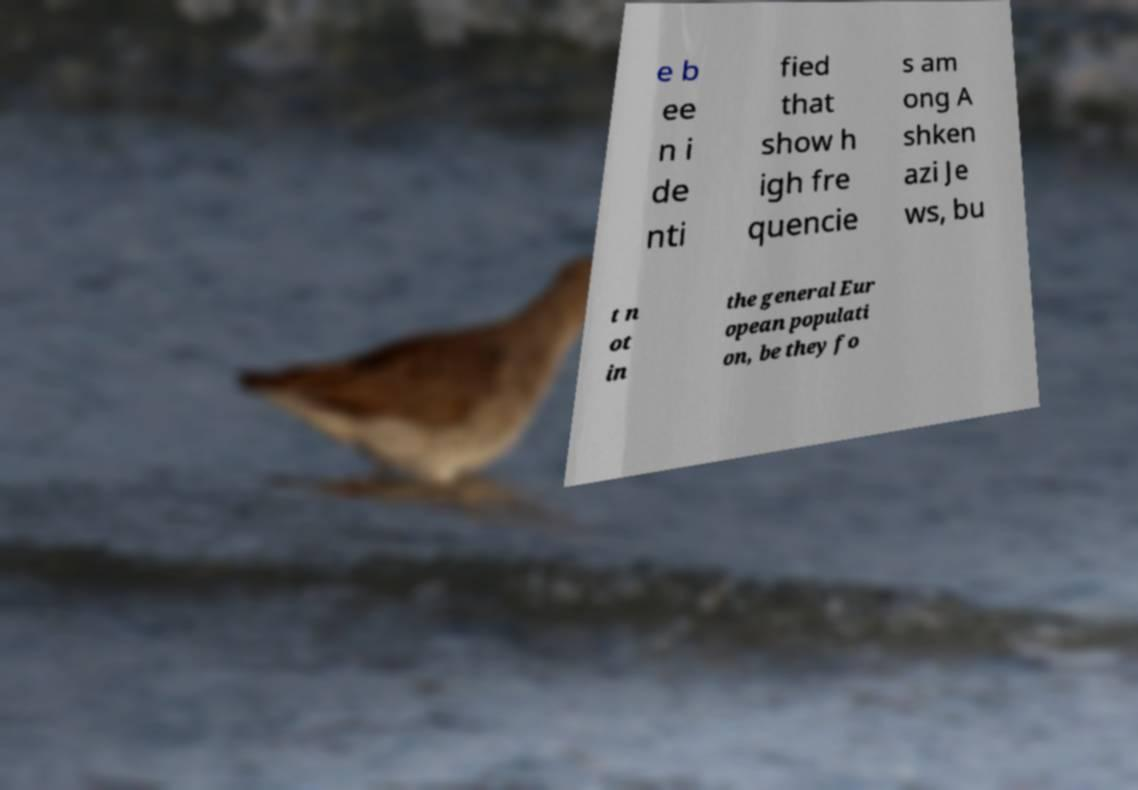Could you assist in decoding the text presented in this image and type it out clearly? e b ee n i de nti fied that show h igh fre quencie s am ong A shken azi Je ws, bu t n ot in the general Eur opean populati on, be they fo 